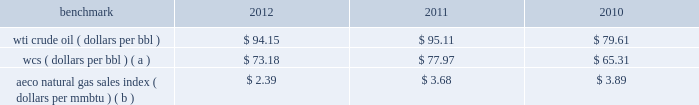Our international crude oil production is relatively sweet and is generally sold in relation to the brent crude benchmark .
The differential between wti and brent average prices widened significantly in 2011 and remained in 2012 in comparison to almost no differential in 2010 .
Natural gas 2013 a significant portion of our natural gas production in the lower 48 states of the u.s .
Is sold at bid-week prices or first-of-month indices relative to our specific producing areas .
Average henry hub settlement prices for natural gas were lower in 2012 than in recent years .
A decline in average settlement date henry hub natural gas prices began in september 2011 and continued into 2012 .
Although prices stabilized in late 2012 , they have not increased appreciably .
Our other major natural gas-producing regions are e.g .
And europe .
In the case of e.g .
Our natural gas sales are subject to term contracts , making realizations less volatile .
Because natural gas sales from e.g .
Are at fixed prices , our worldwide reported average natural gas realizations may not fully track market price movements .
Natural gas prices in europe have been significantly higher than in the u.s .
Oil sands mining the osm segment produces and sells various qualities of synthetic crude oil .
Output mix can be impacted by operational problems or planned unit outages at the mines or upgrader .
Sales prices for roughly two-thirds of the normal output mix will track movements in wti and one-third will track movements in the canadian heavy sour crude oil marker , primarily wcs .
In 2012 , the wcs discount from wti had increased , putting downward pressure on our average realizations .
The operating cost structure of the osm operations is predominantly fixed and therefore many of the costs incurred in times of full operation continue during production downtime .
Per-unit costs are sensitive to production rates .
Key variable costs are natural gas and diesel fuel , which track commodity markets such as the canadian alberta energy company ( "aeco" ) natural gas sales index and crude oil prices , respectively .
The table below shows average benchmark prices that impact both our revenues and variable costs. .
Wcs ( dollars per bbl ) ( a ) $ 73.18 $ 77.97 $ 65.31 aeco natural gas sales index ( dollars per mmbtu ) ( b ) $ 2.39 $ 3.68 $ 3.89 ( a ) monthly pricing based upon average wti adjusted for differentials unique to western canada .
( b ) monthly average day ahead index .
Integrated gas our ig operations include production and marketing of products manufactured from natural gas , such as lng and methanol , in e.g .
World lng trade in 2012 has been estimated to be 240 mmt .
Long-term , lng continues to be in demand as markets seek the benefits of clean burning natural gas .
Market prices for lng are not reported or posted .
In general , lng delivered to the u.s .
Is tied to henry hub prices and will track with changes in u.s .
Natural gas prices , while lng sold in europe and asia is indexed to crude oil prices and will track the movement of those prices .
We have a 60 percent ownership in an lng production facility in e.g. , which sells lng under a long-term contract at prices tied to henry hub natural gas prices .
Gross sales from the plant were 3.8 mmt , 4.1 mmt and 3.7 mmt in 2012 , 2011 and 2010 .
We own a 45 percent interest in a methanol plant located in e.g .
Through our investment in ampco .
Gross sales of methanol from the plant totaled 1.1 mmt , 1.0 mmt and 0.9 mmt in 2012 , 2011 and 2010 .
Methanol demand has a direct impact on ampco 2019s earnings .
Because global demand for methanol is rather limited , changes in the supply-demand balance can have a significant impact on sales prices .
World demand for methanol in 2012 has been estimated to be 49 mmt .
Our plant capacity of 1.1 mmt is about 2 percent of world demand. .
By what percentage did the average price per barrel of wcs increase from 2010 to 2012? 
Computations: ((73.18 - 65.31) / 65.31)
Answer: 0.1205. 